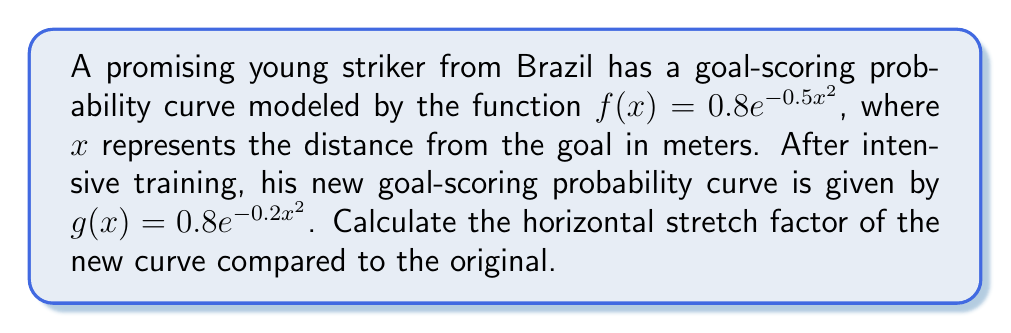Show me your answer to this math problem. To find the horizontal stretch factor, we need to compare the equations of $f(x)$ and $g(x)$:

1) Original function: $f(x) = 0.8e^{-0.5x^2}$
2) New function: $g(x) = 0.8e^{-0.2x^2}$

The general form of a horizontal stretch is:
$g(x) = f(\frac{x}{k})$, where $k$ is the stretch factor.

3) Let's rewrite $g(x)$ in terms of $f(x)$:
   $g(x) = 0.8e^{-0.2x^2} = 0.8e^{-0.5(\frac{x}{\sqrt{2.5}})^2}$

4) This means $g(x) = f(\frac{x}{\sqrt{2.5}})$

5) Therefore, the horizontal stretch factor $k = \sqrt{2.5}$

To verify:
$-0.5(\frac{x}{\sqrt{2.5}})^2 = -0.5 \cdot \frac{x^2}{2.5} = -0.2x^2$

This confirms that the striker's new curve is horizontally stretched by a factor of $\sqrt{2.5}$ compared to his original curve.
Answer: $\sqrt{2.5}$ 